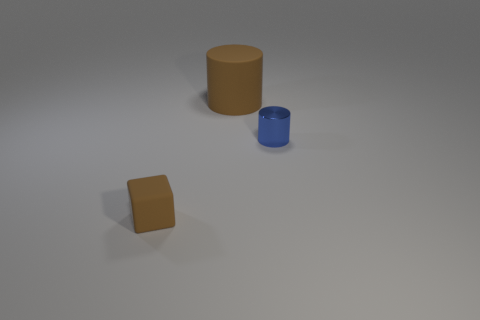Add 2 tiny blue things. How many objects exist? 5 Subtract all cubes. How many objects are left? 2 Add 2 blue metal objects. How many blue metal objects are left? 3 Add 2 small purple metal cylinders. How many small purple metal cylinders exist? 2 Subtract 0 blue blocks. How many objects are left? 3 Subtract all brown objects. Subtract all tiny matte blocks. How many objects are left? 0 